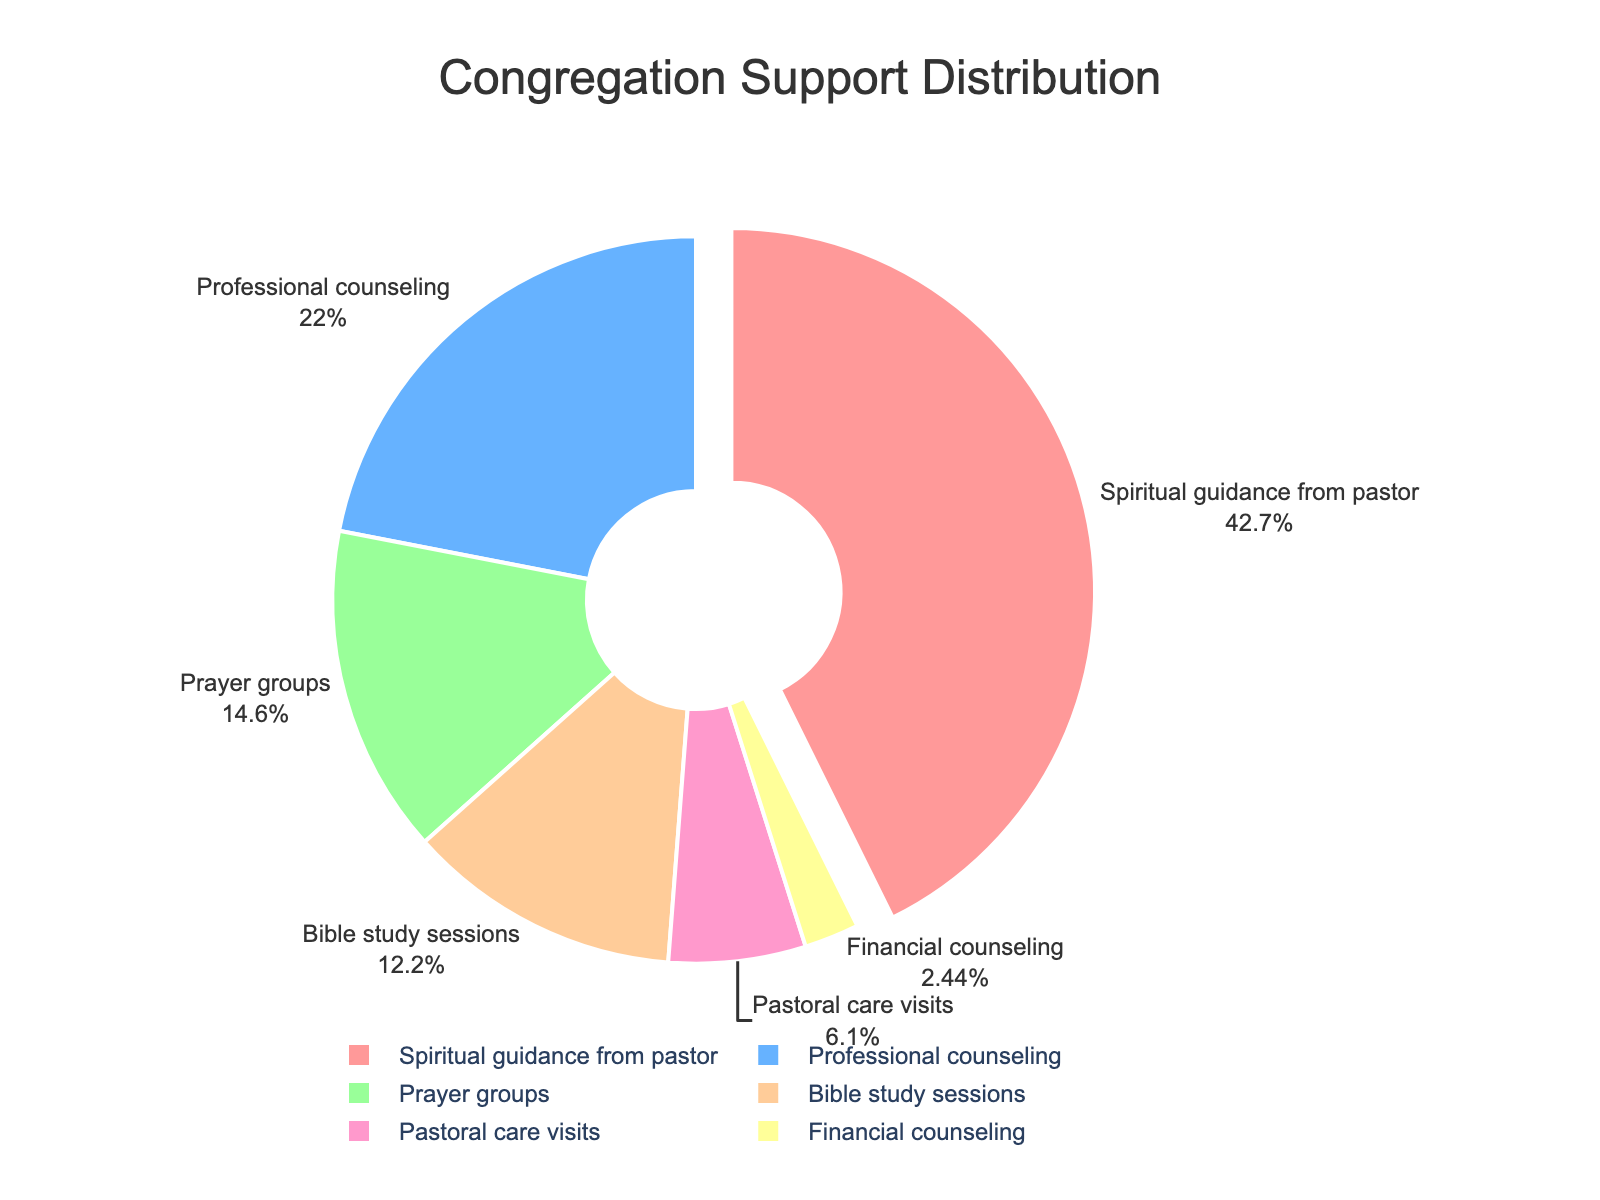What type of support is most sought after by congregation members? To determine the most sought type of support, look at the section of the pie chart representing the highest percentage. The pie chart indicates that "Spiritual guidance from pastor" has the largest segment.
Answer: Spiritual guidance from pastor Which is preferred more, professional counseling or prayer groups? Compare the segments for "Professional counseling" and "Prayer groups" by looking at their percentages. "Professional counseling" has 18% whereas "Prayer groups" has 12%. Therefore, professional counseling is preferred more.
Answer: Professional counseling What is the combined percentage of congregation members seeking prayer groups and Bible study sessions? Add the percentages of "Prayer groups" (12%) and "Bible study sessions" (10%) for the combined percentage. The sum is 12% + 10% = 22%.
Answer: 22% How does the percentage of members seeking financial counseling compare to that seeking pastoral care visits? Compare the percentages of "Financial counseling" (2%) and "Pastoral care visits" (5%). "Financial counseling" is less than "Pastoral care visits" by 3 percentage points.
Answer: Financial counseling is less than pastoral care visits Which section of the pie chart has the second largest pull effect? The largest pull effect is on "Spiritual guidance from pastor" which is highlighted by being pulled out the most. To find the second largest, observe any other sections with a noticeable pull effect. However, only "Spiritual guidance from pastor" has a pull effect, so no other sections have a pull effect.
Answer: None What is the difference in percentage between the most and least sought types of support? Identify the segments with the highest and lowest percentages. "Spiritual guidance from pastor" has 35% and "Financial counseling" has 2%. The difference is 35% - 2% = 33%.
Answer: 33% What percentage of members seek either professional counseling or pastoral care visits? Add the percentages of "Professional counseling" (18%) and "Pastoral care visits" (5%) for the combined percentage. The sum is 18% + 5% = 23%.
Answer: 23% What color represents Bible study sessions in the pie chart? Look for the segment labeled "Bible study sessions" and note its color. The pie chart uses distinct colors for each section. "Bible study sessions" is in a unique color that can be seen visually.
Answer: Color for Bible study sessions How many types of support have a percentage greater than 10%? Count the segments whose percentages are greater than 10%. These are "Spiritual guidance from pastor" (35%), "Professional counseling" (18%), "Prayer groups" (12%), and "Bible study sessions" (10%). So there are three types with percentages greater than 10%.
Answer: 3 